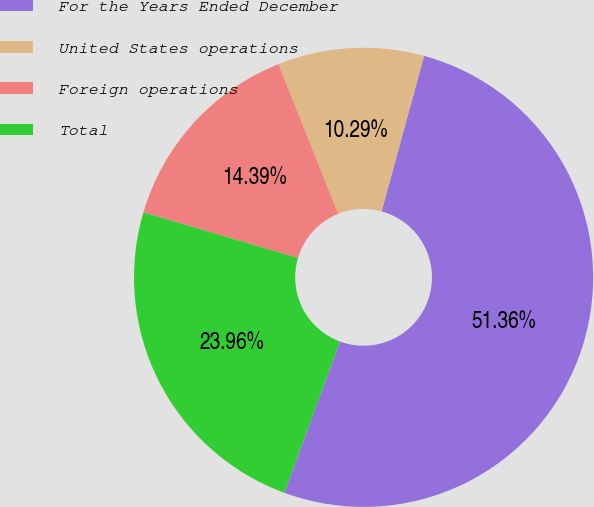Convert chart to OTSL. <chart><loc_0><loc_0><loc_500><loc_500><pie_chart><fcel>For the Years Ended December<fcel>United States operations<fcel>Foreign operations<fcel>Total<nl><fcel>51.36%<fcel>10.29%<fcel>14.39%<fcel>23.96%<nl></chart> 